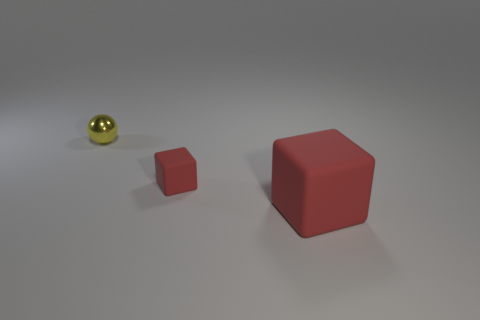Can you compare the materials of the objects shown? Certainly! In the image, we have objects that appear to be made of different materials. The red objects have a matte finish, suggesting they might be made of rubber. The small object on the far left shines and reflects light, indicating that it could be made of a polished metal, possibly brass or gold in color. 